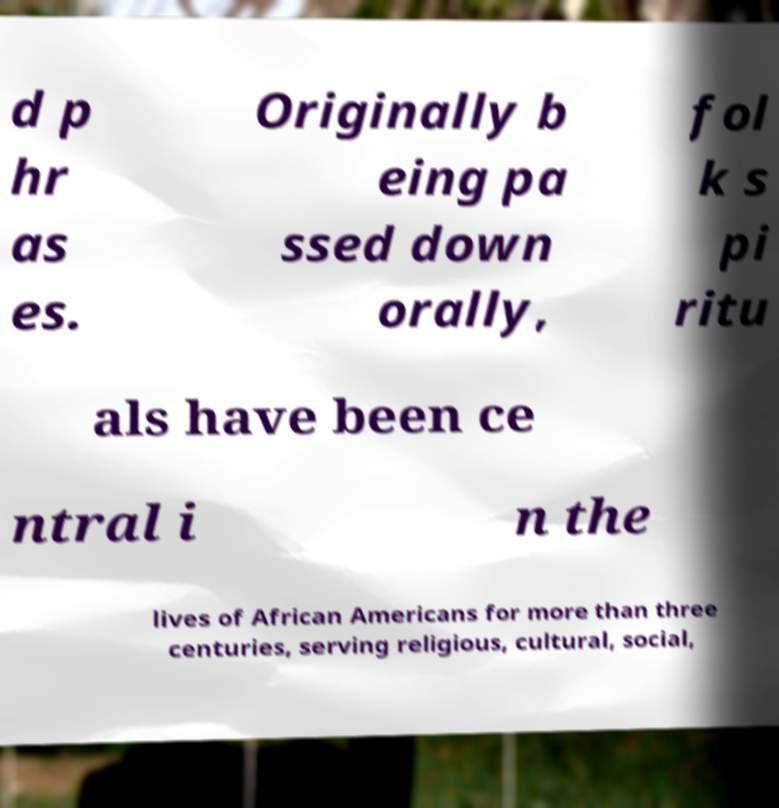There's text embedded in this image that I need extracted. Can you transcribe it verbatim? d p hr as es. Originally b eing pa ssed down orally, fol k s pi ritu als have been ce ntral i n the lives of African Americans for more than three centuries, serving religious, cultural, social, 